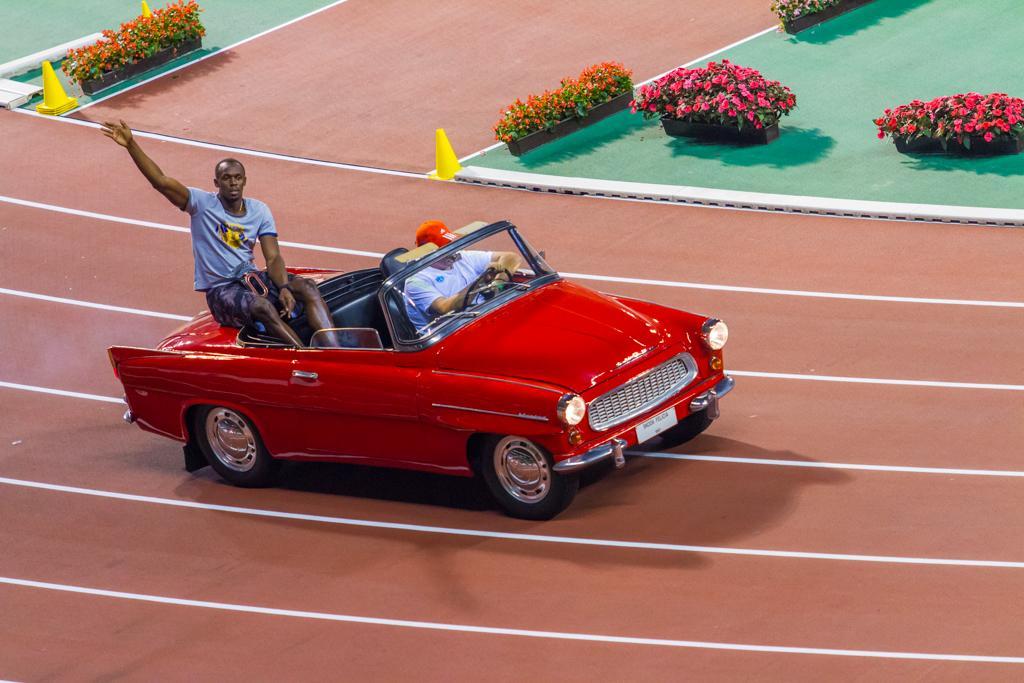Describe this image in one or two sentences. In this image I can see two persons are sitting in the car. On the top of the image I can see some flower pots. The car is in red color and the persons are wearing white color t-shirts in that one person is wearing orange color cap on his head. 